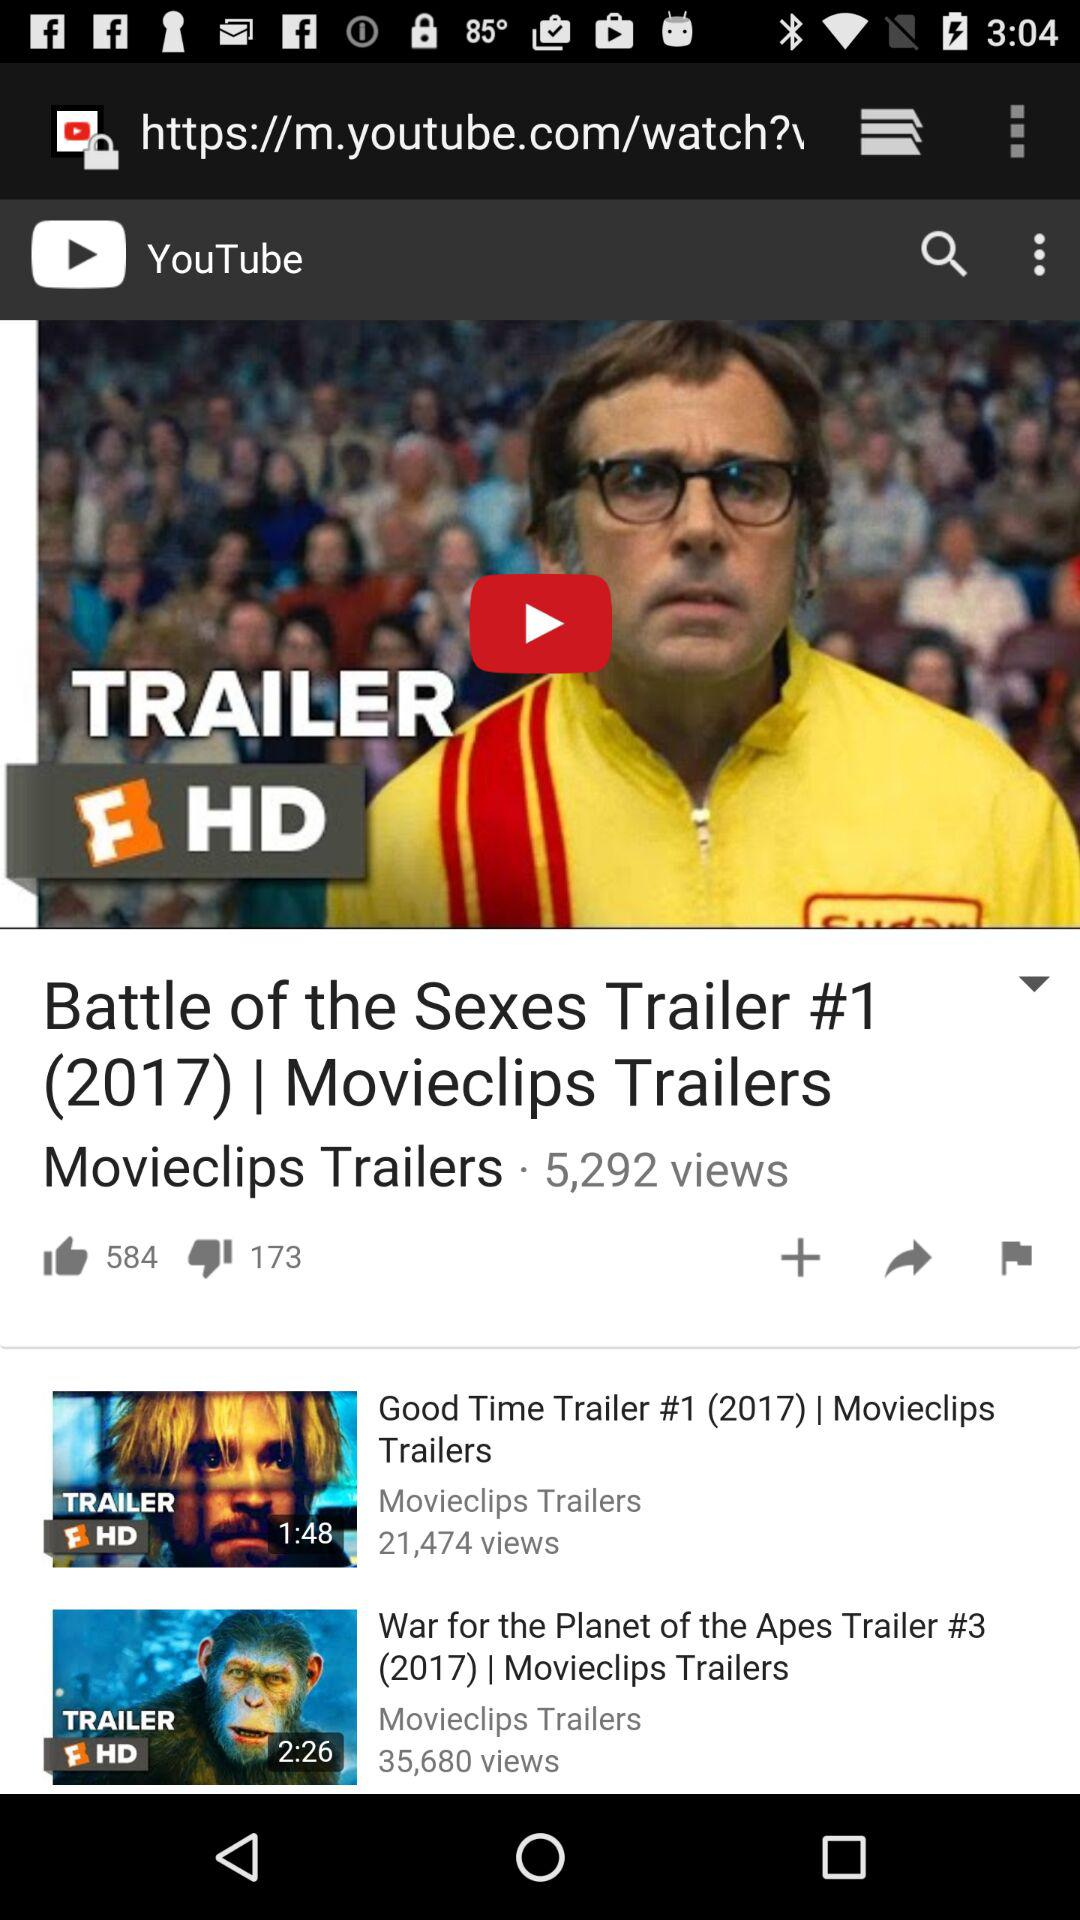How many views are there for "Battle of the Sexes Trailer #1 (2017)"? There are 5,292 views. 